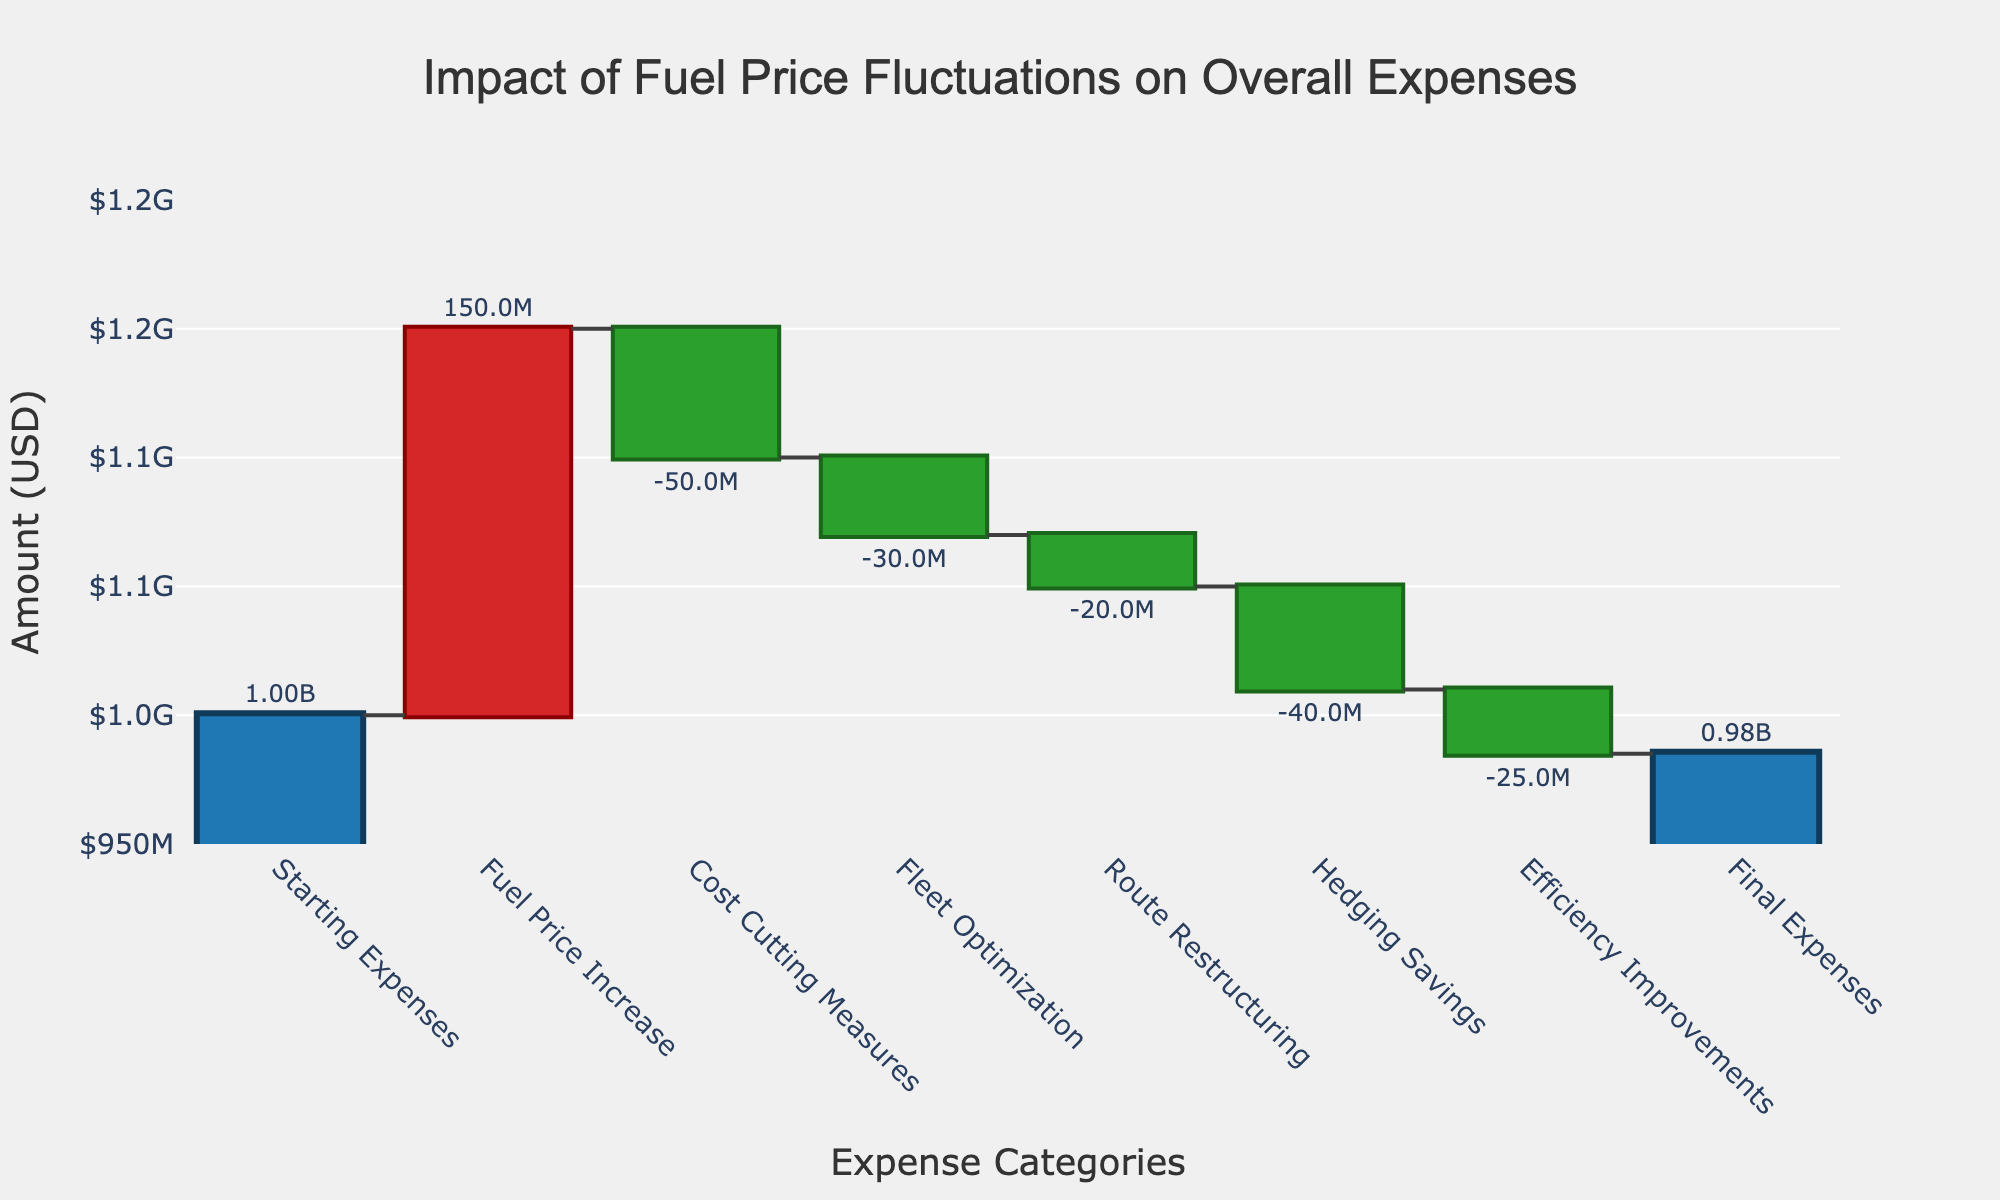What is the title of the chart? The title of the chart is located at the top center of the figure. It provides a concise description of what the chart represents.
Answer: Impact of Fuel Price Fluctuations on Overall Expenses What is the starting expense amount? The starting expense amount is the first data point on the chart, usually distinguished by being an "absolute" value.
Answer: 1.00B How much did fuel price increases add to the expenses? The increase due to fuel prices is represented by an upward bar following the starting expenses, typically marked in red or another distinct color.
Answer: 150M Which measure contributed the most to reducing the expenses? Compare the downward bars that signify expense reductions to identify the largest one.
Answer: Cost Cutting Measures By how much did route restructuring impact overall expenses? Find the value associated with the "Route Restructuring" category, which will be shown as a downward bar.
Answer: -20M What is the final expense amount? The final expense amount is indicated by the last data point on the chart, which is a "total" marked differently from the other categories.
Answer: 985M How does fleet optimization compare to hedging savings in terms of expense reduction? Compare the values of "Fleet Optimization" and "Hedging Savings." Fleet Optimization: -30M, Hedging Savings: -40M.
Answer: Hedging had a larger expense reduction What is the net change in expenses considering all fluctuations shown in the chart? Calculate the net change by summing up all the values on the chart, starting with the initial expense and including both increases and decreases. Starting Expenses (1.00B) + Fuel Price Increase (150M) - Cost Cutting Measures (50M) - Fleet Optimization (30M) - Route Restructuring (20M) - Hedging Savings (40M) - Efficiency Improvements (25M) = 985M
Answer: 985M 